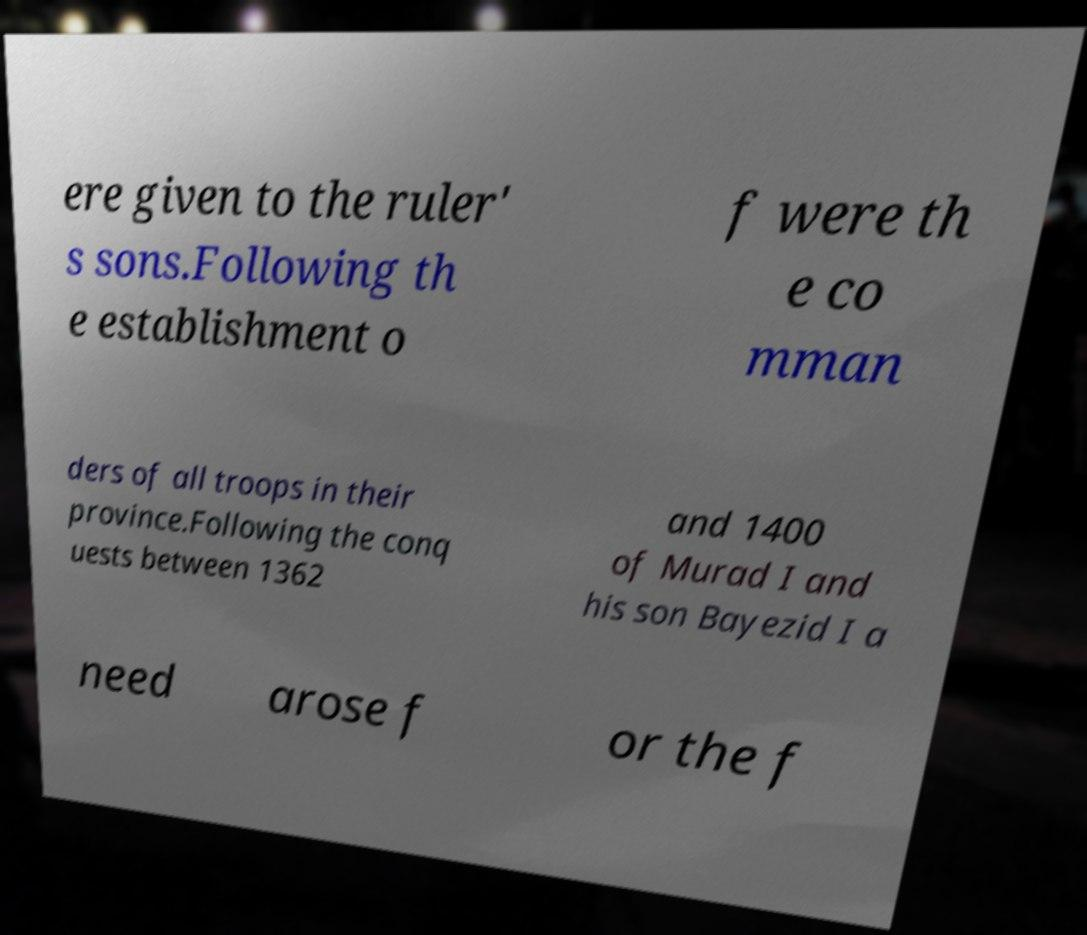Can you read and provide the text displayed in the image?This photo seems to have some interesting text. Can you extract and type it out for me? ere given to the ruler' s sons.Following th e establishment o f were th e co mman ders of all troops in their province.Following the conq uests between 1362 and 1400 of Murad I and his son Bayezid I a need arose f or the f 